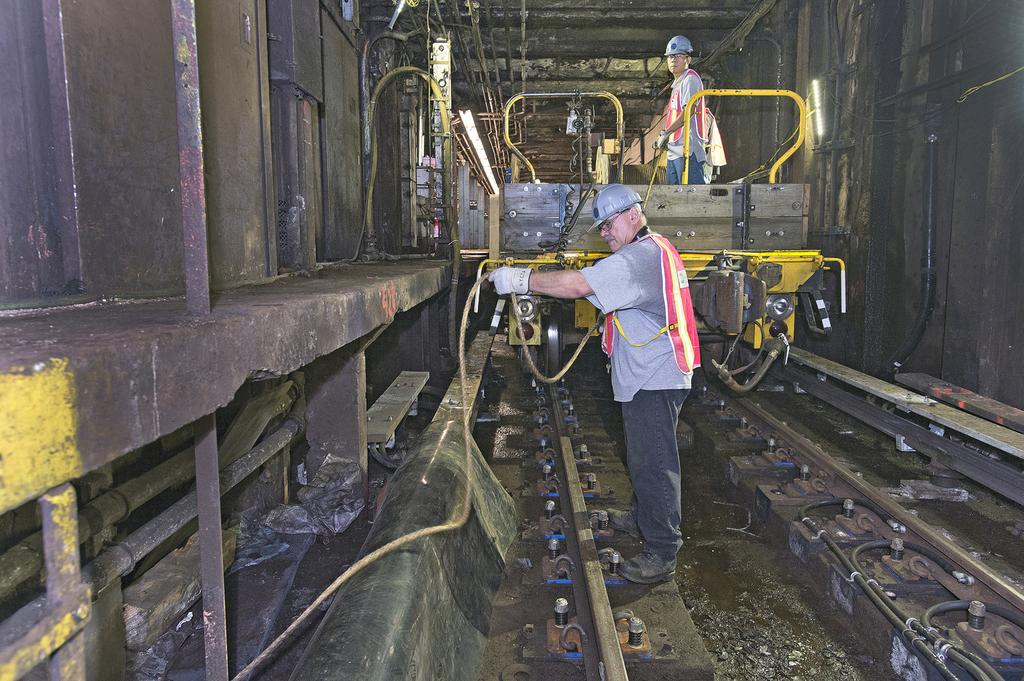What is the person holding in the image? The person is holding a pipe in the image. What is the man doing in the image? The man is standing on a vehicle in the image. What type of transportation might be associated with the vehicle? The vehicle might be a train, given the presence of a railway track in the image. What type of game is being played on the bridge in the image? There is no bridge or game present in the image; it features a person holding a pipe and a man standing on a vehicle near a railway track. What color is the string tied to the person's wrist in the image? There is no string tied to the person's wrist in the image. 